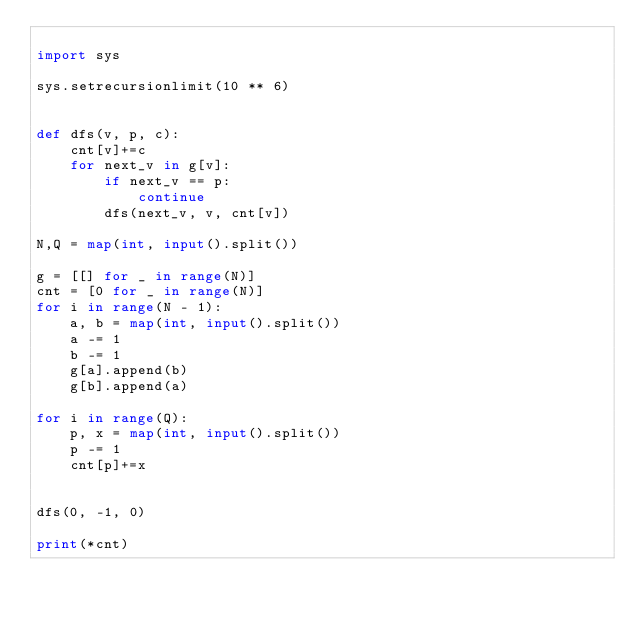<code> <loc_0><loc_0><loc_500><loc_500><_Python_>
import sys

sys.setrecursionlimit(10 ** 6)


def dfs(v, p, c):
    cnt[v]+=c
    for next_v in g[v]:
        if next_v == p:
            continue
        dfs(next_v, v, cnt[v])

N,Q = map(int, input().split())

g = [[] for _ in range(N)]
cnt = [0 for _ in range(N)]
for i in range(N - 1):
    a, b = map(int, input().split())
    a -= 1
    b -= 1
    g[a].append(b)
    g[b].append(a)

for i in range(Q):
    p, x = map(int, input().split())
    p -= 1
    cnt[p]+=x


dfs(0, -1, 0)

print(*cnt)</code> 